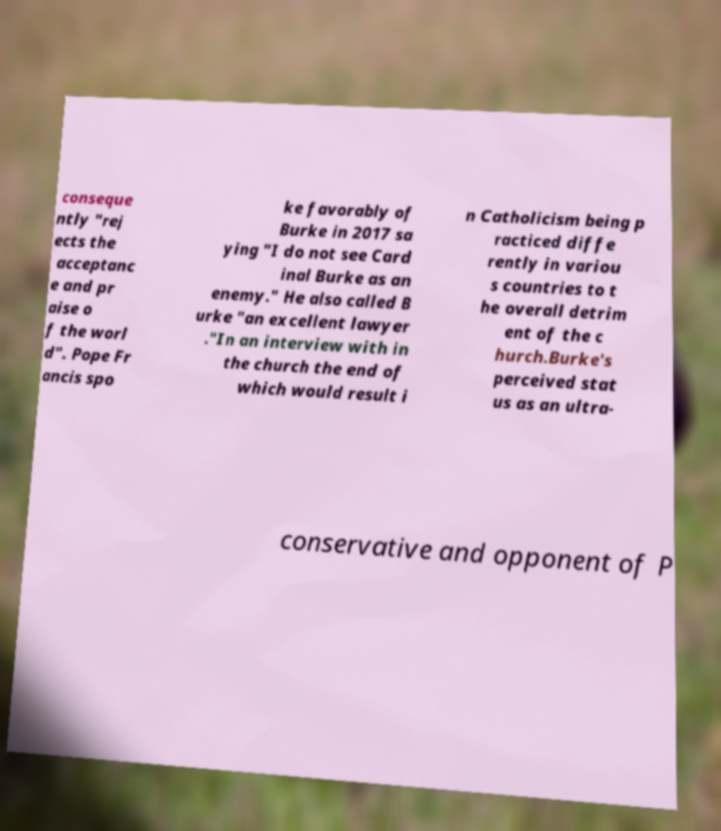Could you extract and type out the text from this image? conseque ntly "rej ects the acceptanc e and pr aise o f the worl d". Pope Fr ancis spo ke favorably of Burke in 2017 sa ying "I do not see Card inal Burke as an enemy." He also called B urke "an excellent lawyer ."In an interview with in the church the end of which would result i n Catholicism being p racticed diffe rently in variou s countries to t he overall detrim ent of the c hurch.Burke's perceived stat us as an ultra- conservative and opponent of P 